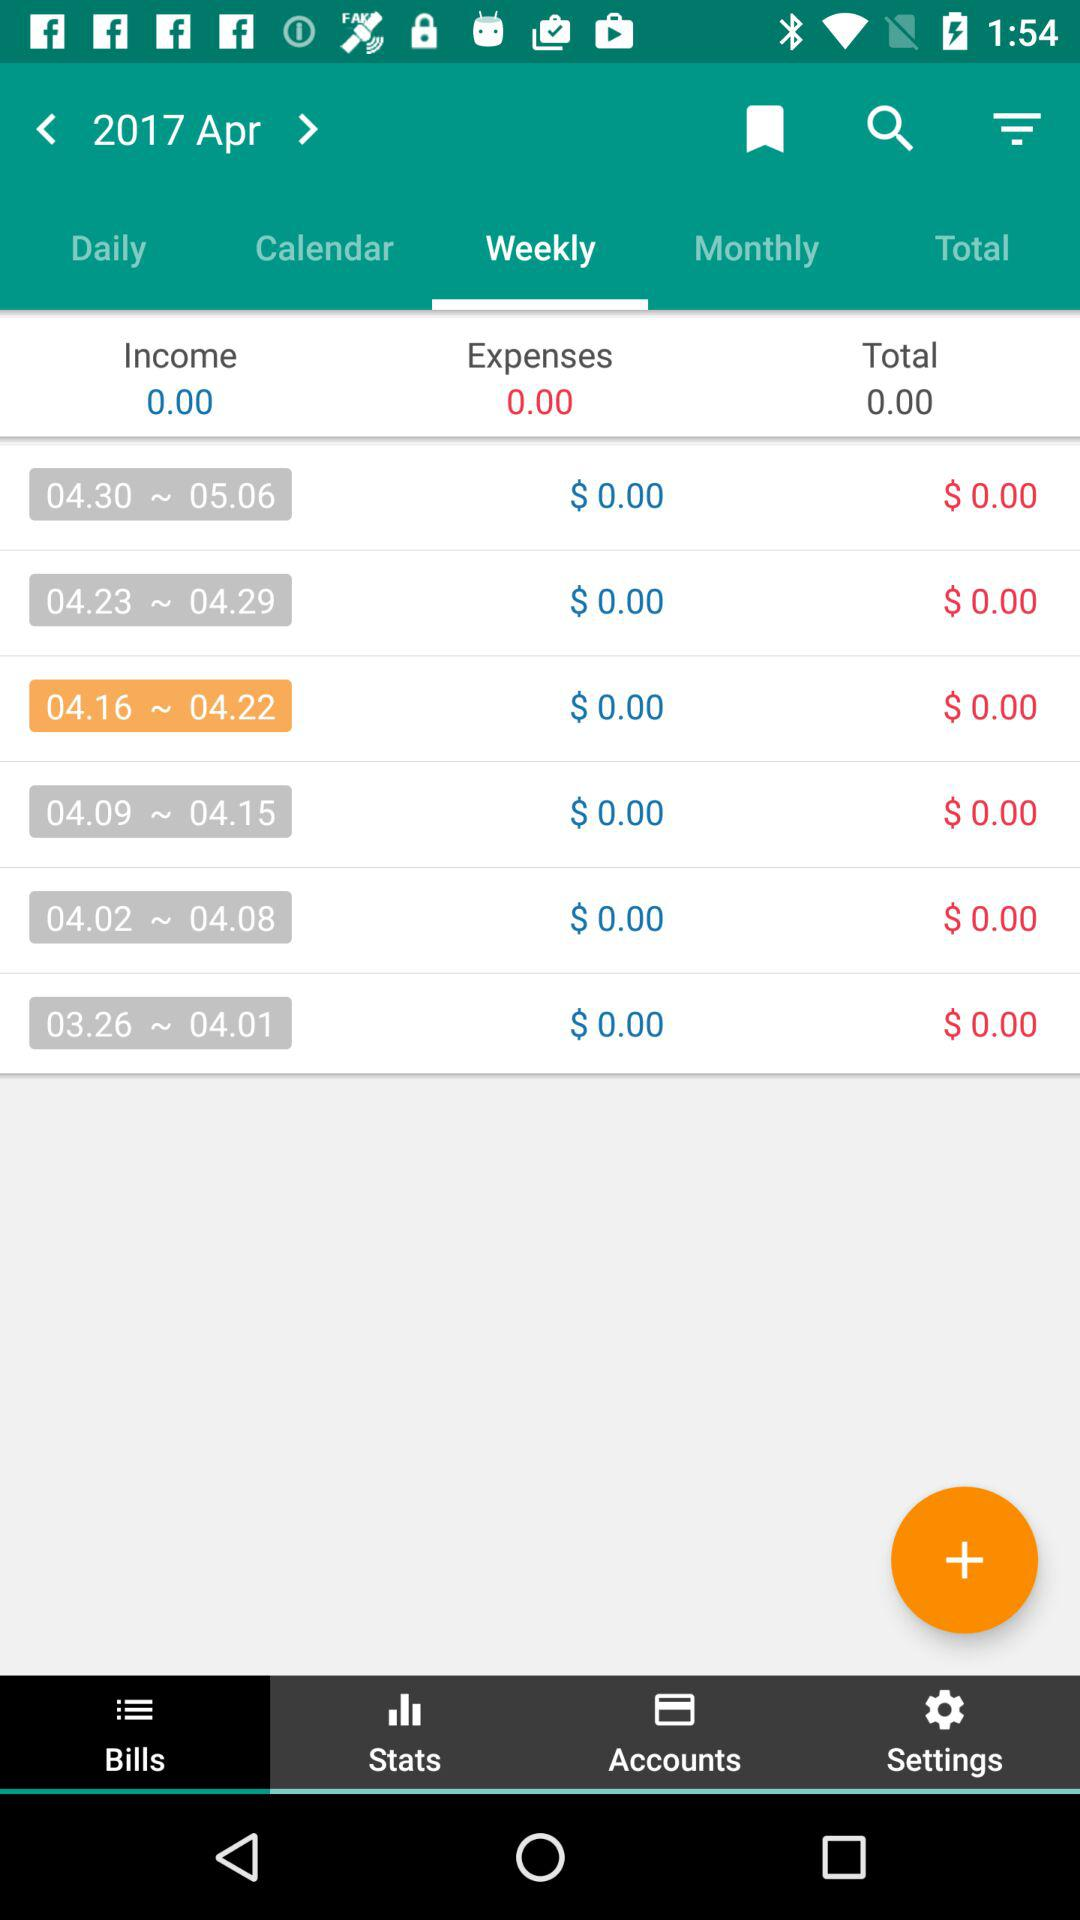Which tab is selected? The selected tab is "Weekly". 